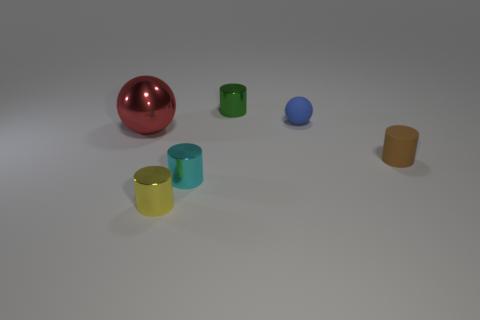Subtract all small green cylinders. How many cylinders are left? 3 Subtract all cylinders. How many objects are left? 2 Add 2 big shiny spheres. How many objects exist? 8 Subtract all brown cylinders. How many cylinders are left? 3 Subtract 0 green blocks. How many objects are left? 6 Subtract 2 cylinders. How many cylinders are left? 2 Subtract all green spheres. Subtract all cyan blocks. How many spheres are left? 2 Subtract all brown cubes. How many green cylinders are left? 1 Subtract all large blue things. Subtract all small balls. How many objects are left? 5 Add 5 small cylinders. How many small cylinders are left? 9 